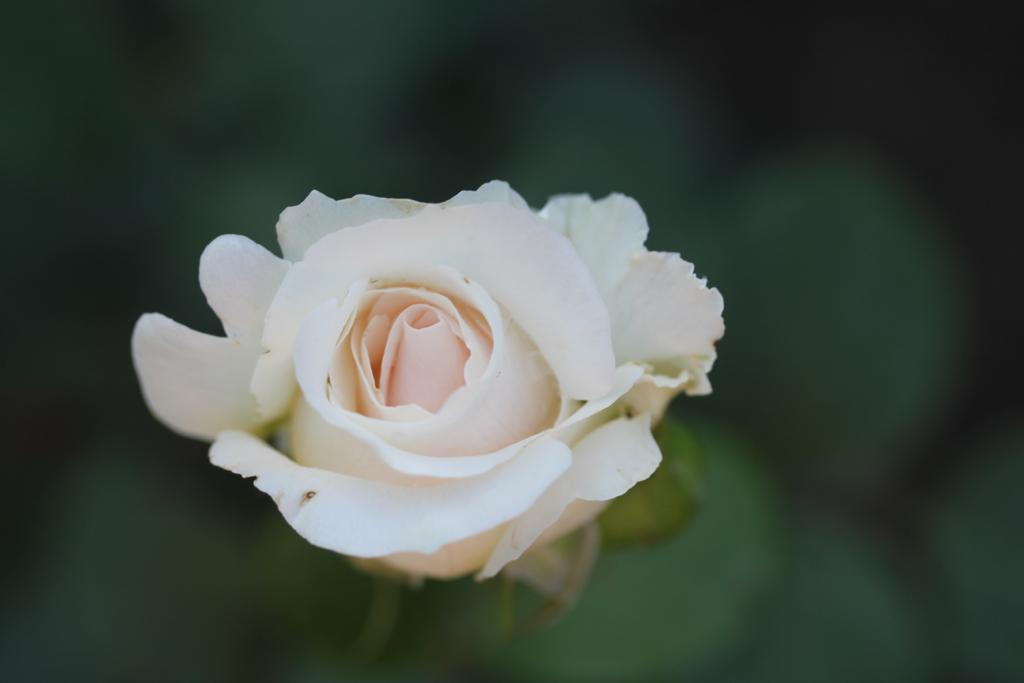Where was the image taken? The image was taken outdoors. What can be observed about the background of the image? The background of the image is blurred. What is the main subject of the image? There is a flower in the middle of the image. What is the color of the flower? The flower is white in color. How much money is being exchanged in the image? There is no money being exchanged in the image; it features a white flower in the outdoors. What type of silk is being used to make the flower in the image? The image does not depict a silk flower; it is a real white flower. 